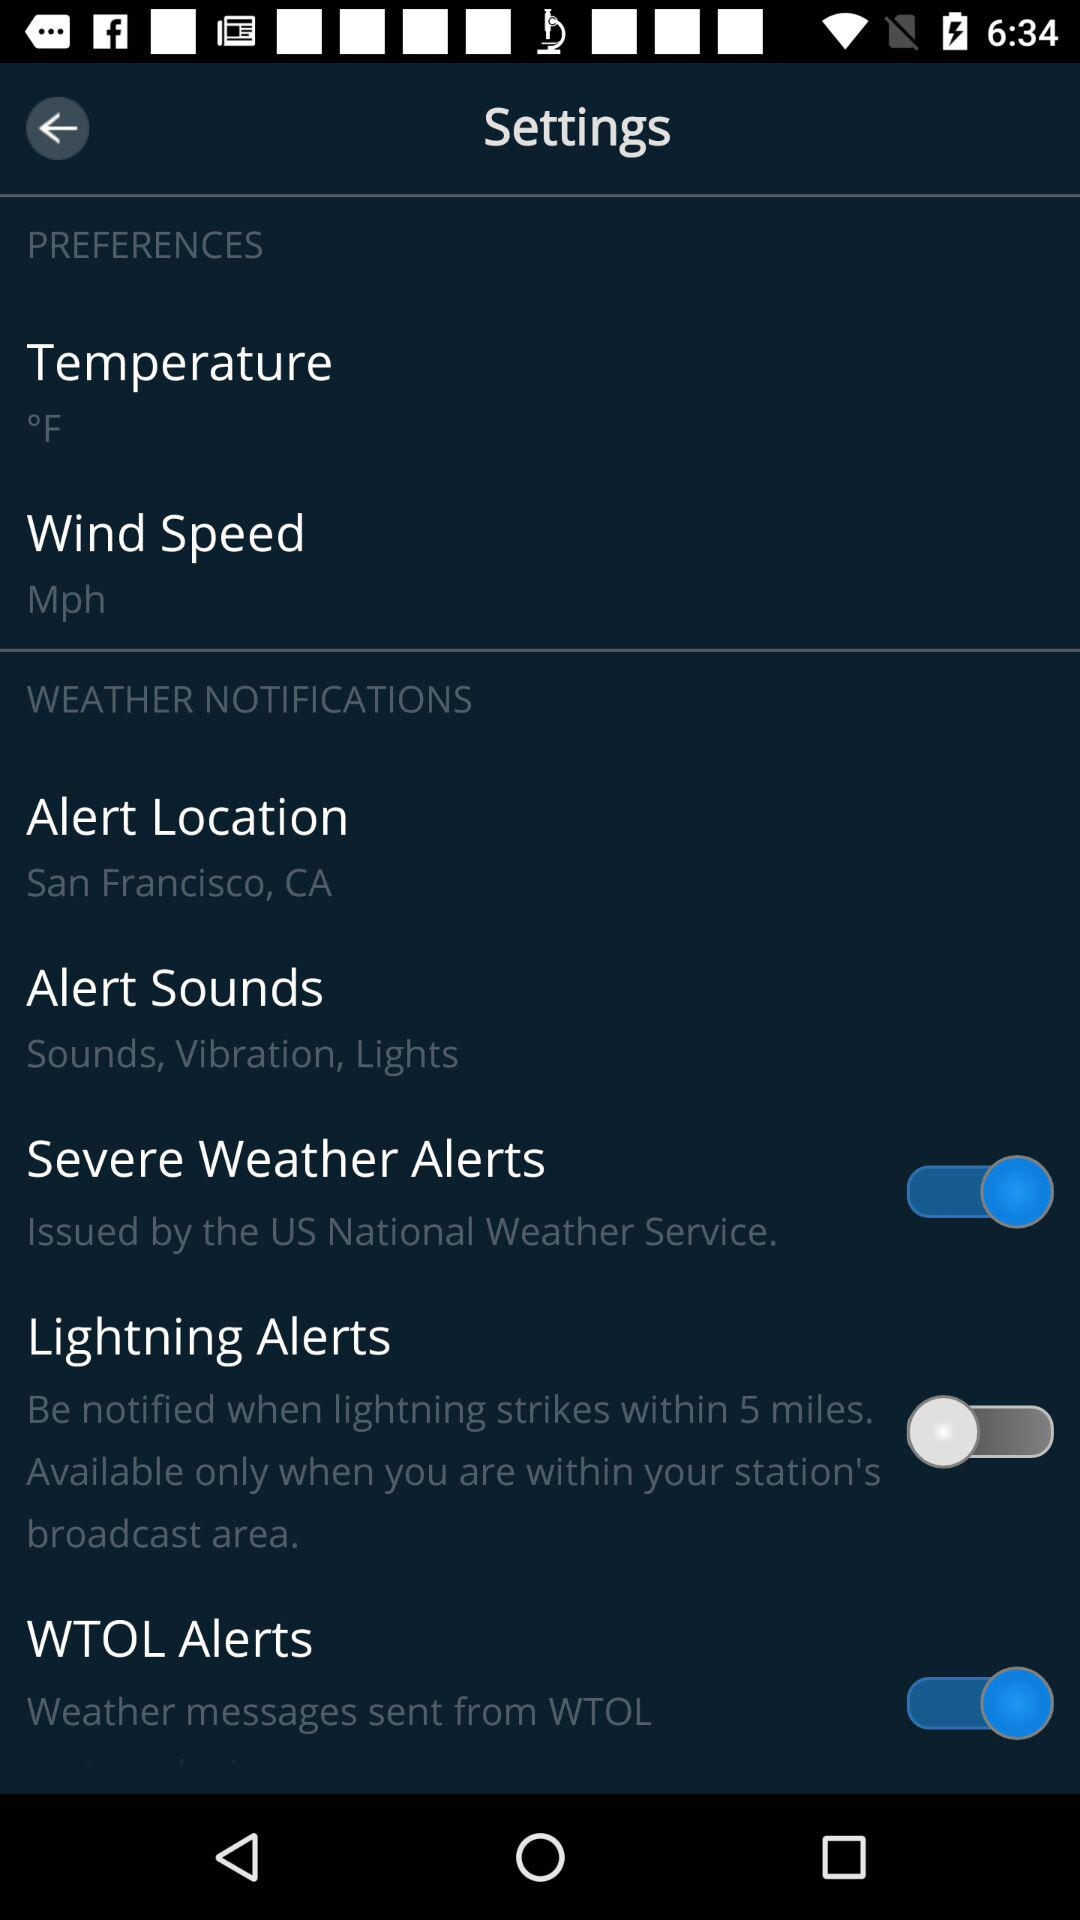How many of the weather notifications are enabled?
Answer the question using a single word or phrase. 2 